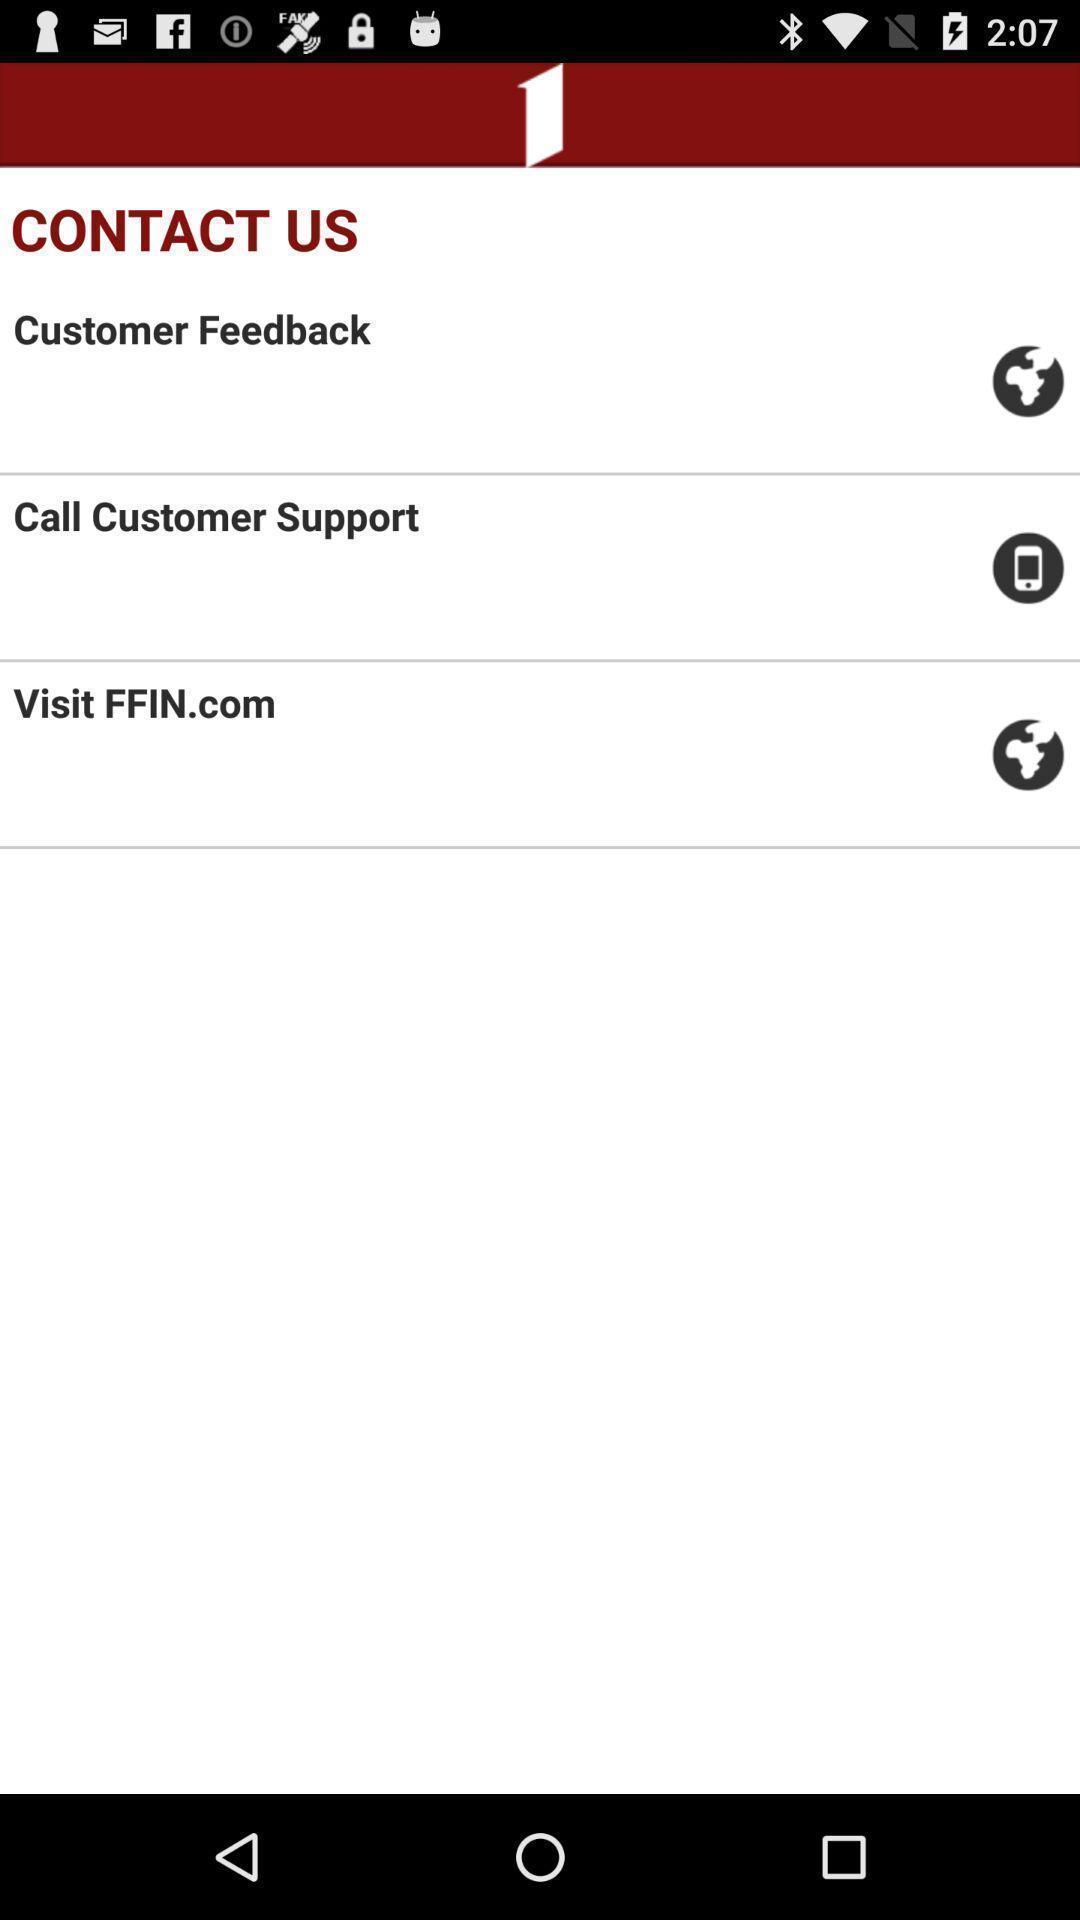Summarize the main components in this picture. Screen shows contact us details. 